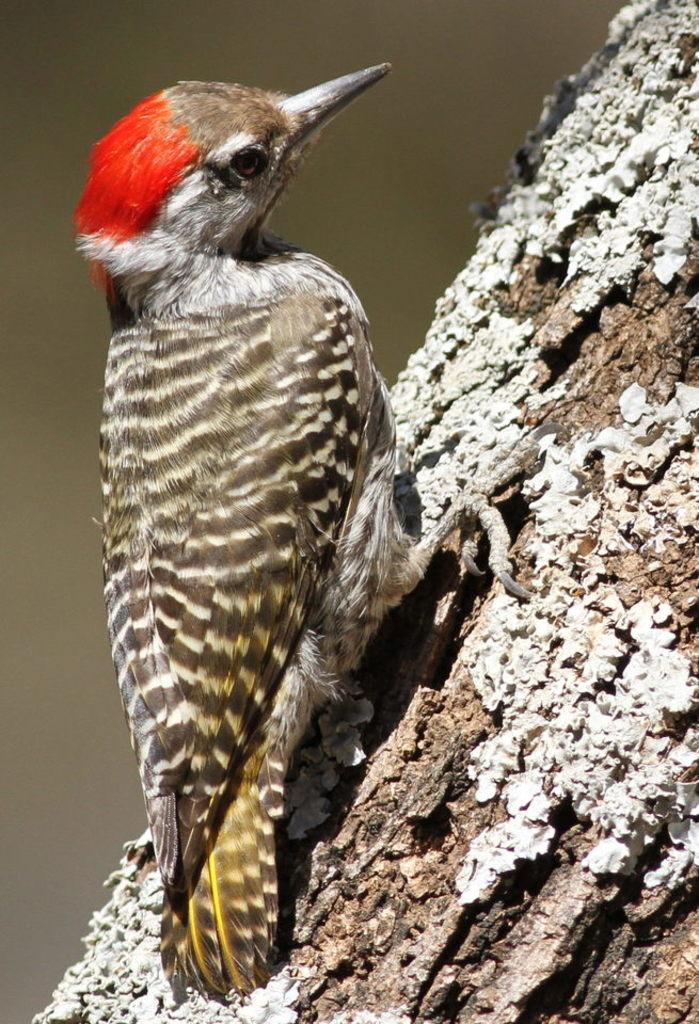What type of animal is present in the image? There is a bird in the image. Where is the bird located? The bird is standing on a tree trunk. How much money does the bird have in the image? There is no indication of money or any financial transactions involving the bird in the image. 